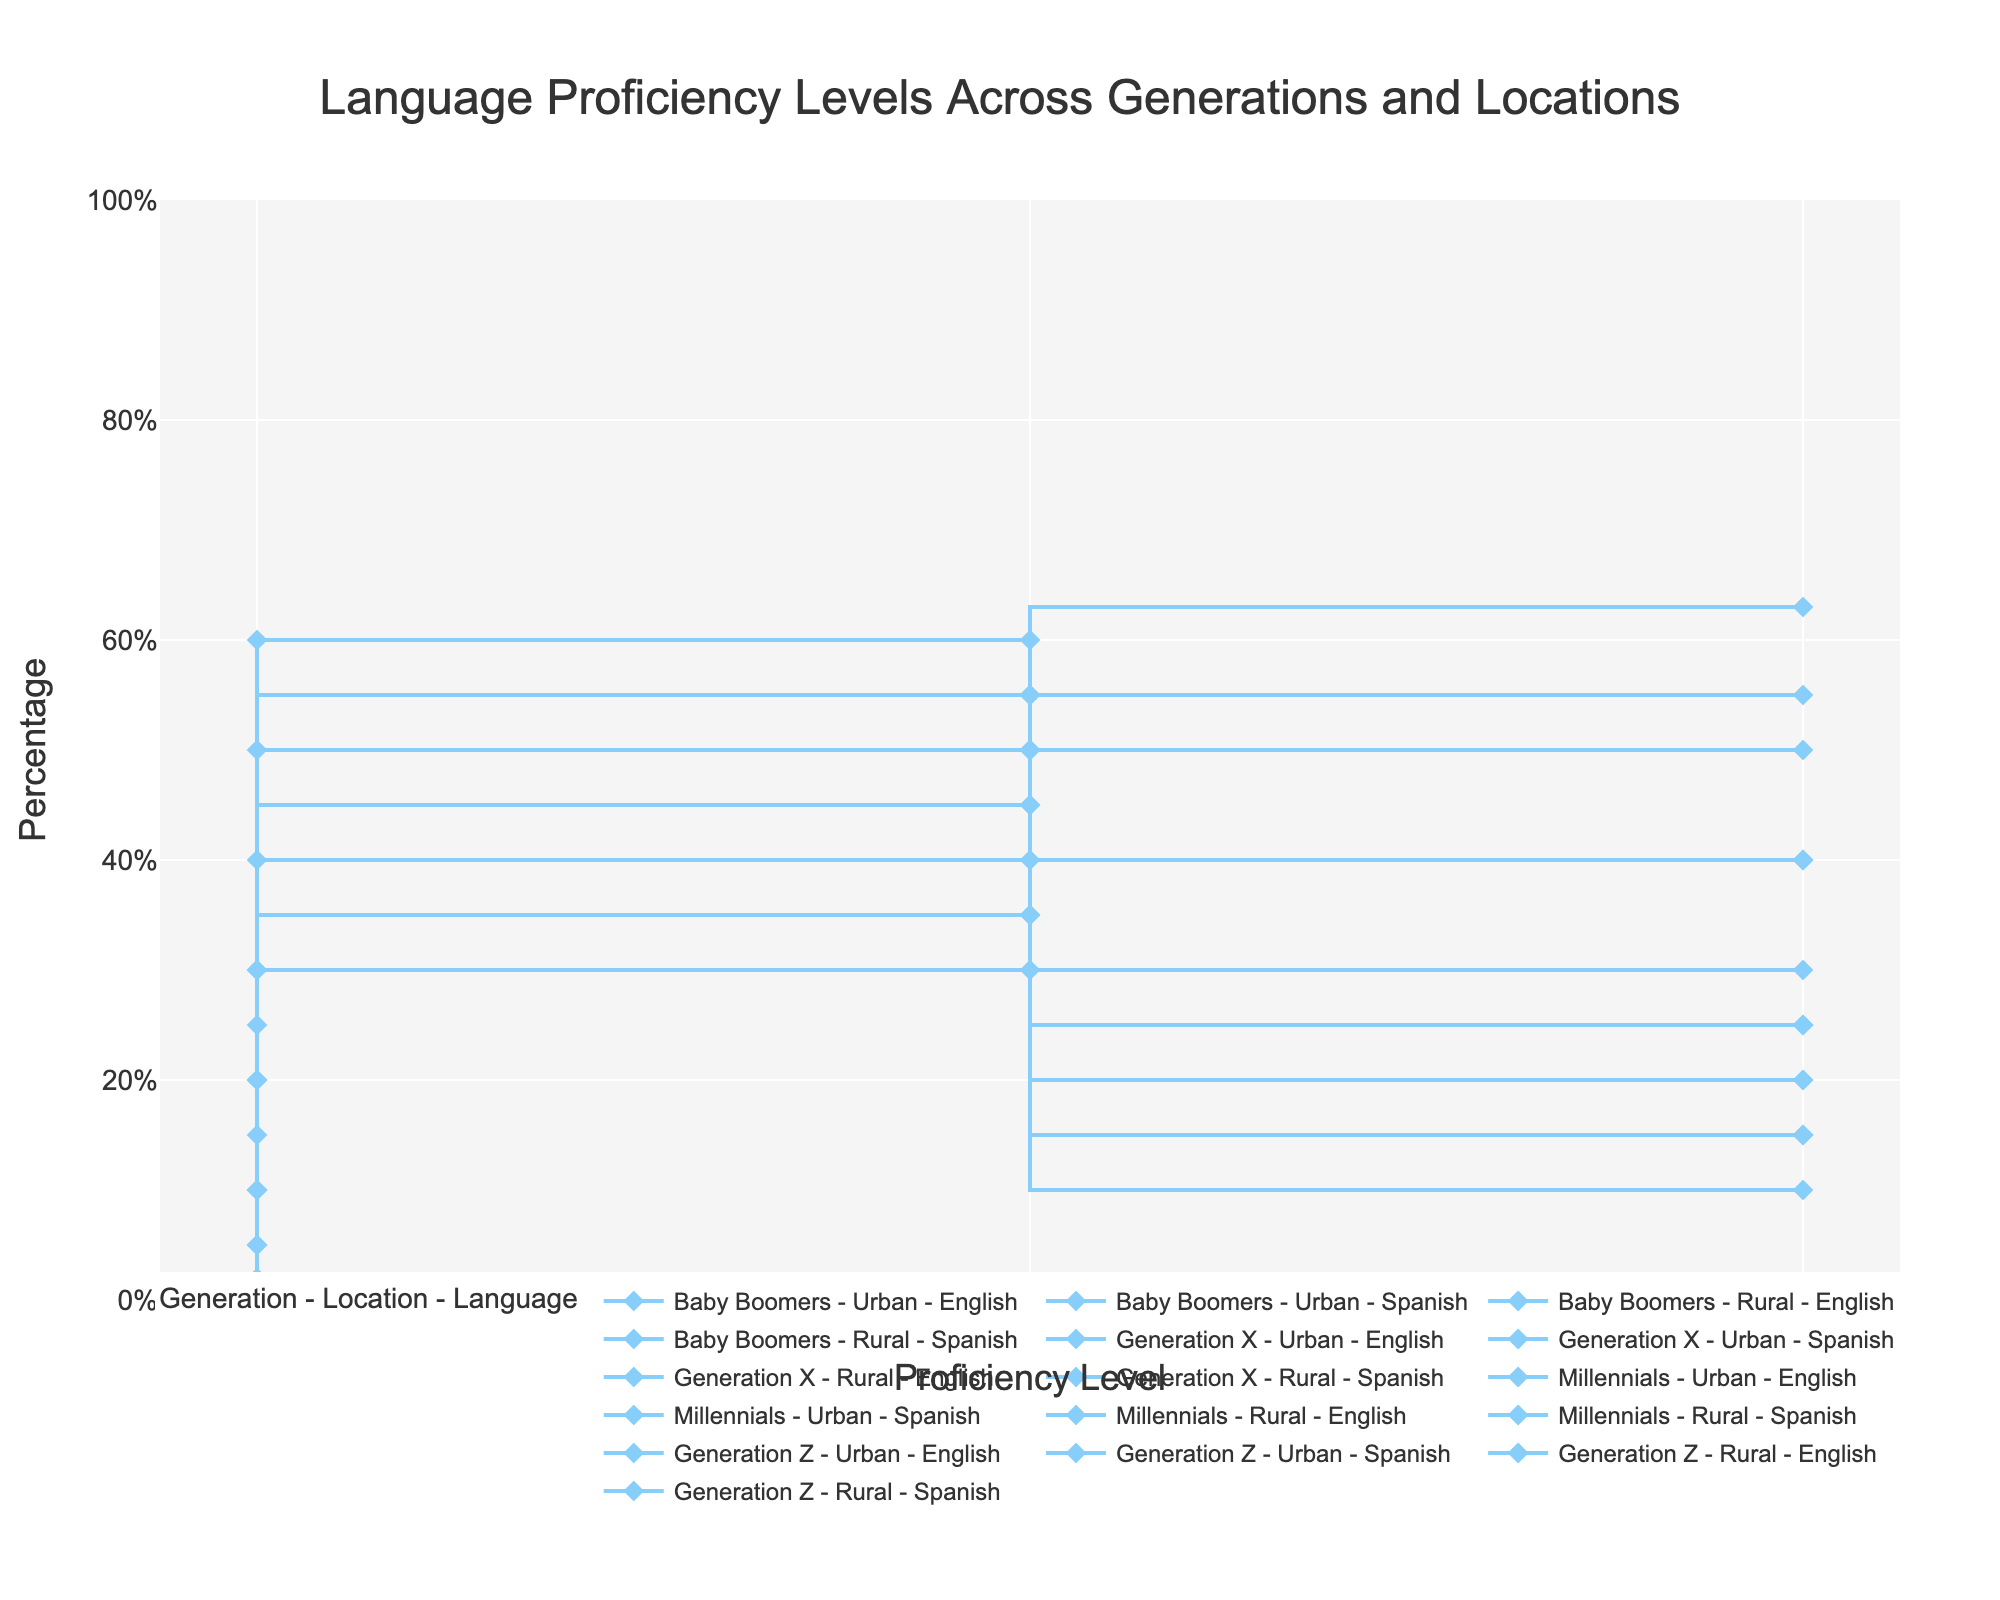What is the title of the figure? The title of the figure is located at the top center.
Answer: Language Proficiency Levels Across Generations and Locations Which proficiency level has the highest percentage for Generation Z in Urban areas for English? Look for the line representing Generation Z in urban areas for English, and identify the highest point on the y-axis.
Answer: Advanced What is the percentage of Baby Boomers in Rural areas with Intermediate Spanish proficiency? Check the line for Baby Boomers in rural areas regarding Spanish, and look for the point corresponding to Intermediate proficiency.
Answer: 30% Among all generations in Urban areas, which group shows the highest percentage of Advanced proficiency in English? Compare the highest points on the y-axis corresponding to Advanced proficiency in Urban English across all generations.
Answer: Generation Z How does the Intermediate proficiency percentage in Spanish for Generation X in Rural areas compare to that of Baby Boomers in Rural areas? Analyze the Intermediate proficiency percentage points for both Generation X and Baby Boomers in Rural Spanish. Generation X has 35%, while Baby Boomers have 30%.
Answer: Generation X is higher by 5% Which generation and location show the lowest percentage of Beginner proficiency in English? Identify the data lines for all generations and locations for Beginner proficiency in English and find the lowest value on the y-axis.
Answer: Generation Z in Urban areas What is the difference in the percentage of Advanced proficiency in Spanish between Millennials in Urban and Rural areas? Locate the Advanced proficiency points for Millennials in Urban and Rural areas for Spanish, and calculate the difference (25% in Urban, 20% in Rural).
Answer: 5% Which language and proficiency level combination has the smallest gap between Urban and Rural areas for Generation X? Compare the percentage differences between Urban and Rural areas for Generation X for each proficiency level in both languages.
Answer: Advanced Spanish How does the percentage of Intermediate proficiency in English for Millennials in Urban areas compare to that of Generation X in the same location? Identify the Intermediate proficiency points for both Millennials and Generation X in Urban areas for English and compare them (45% for Millennials, 50% for Generation X).
Answer: Millennials is 5% lower What is the average percentage of Beginner proficiency in Rural areas across all generations for Spanish? Sum the Beginner proficiency percentages for all generations in Rural areas for Spanish and divide by the count (60% for Baby Boomers, 50% for Generation X, 30% for Millennials, 20% for Generation Z). (60 + 50 + 30 + 20) / 4 = 40%
Answer: 40% 